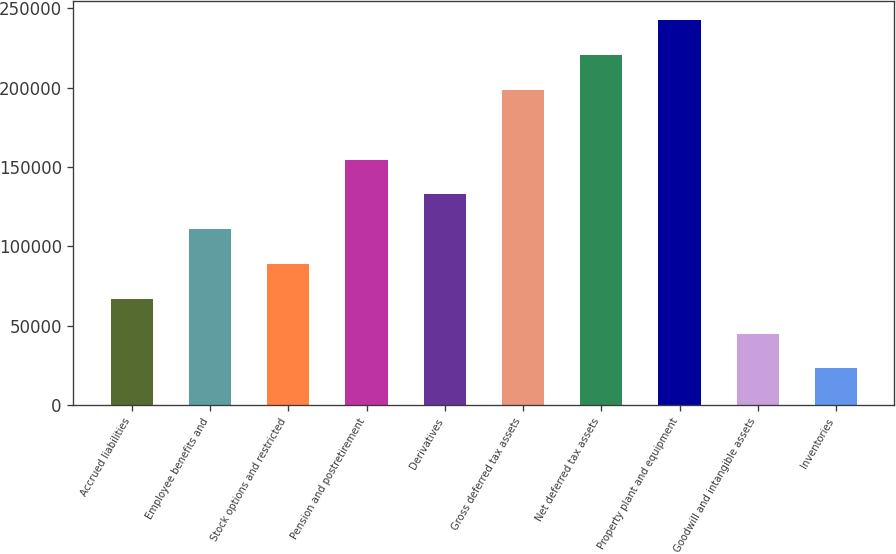Convert chart. <chart><loc_0><loc_0><loc_500><loc_500><bar_chart><fcel>Accrued liabilities<fcel>Employee benefits and<fcel>Stock options and restricted<fcel>Pension and postretirement<fcel>Derivatives<fcel>Gross deferred tax assets<fcel>Net deferred tax assets<fcel>Property plant and equipment<fcel>Goodwill and intangible assets<fcel>Inventories<nl><fcel>66904.8<fcel>110762<fcel>88833.4<fcel>154619<fcel>132691<fcel>198476<fcel>220405<fcel>242334<fcel>44976.2<fcel>23047.6<nl></chart> 